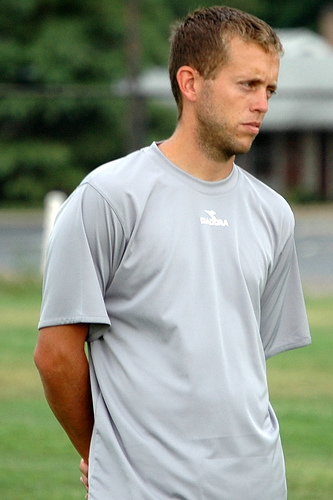<image>
Can you confirm if the man is next to the shirt? No. The man is not positioned next to the shirt. They are located in different areas of the scene. Where is the tree in relation to the roof? Is it in front of the roof? No. The tree is not in front of the roof. The spatial positioning shows a different relationship between these objects. 